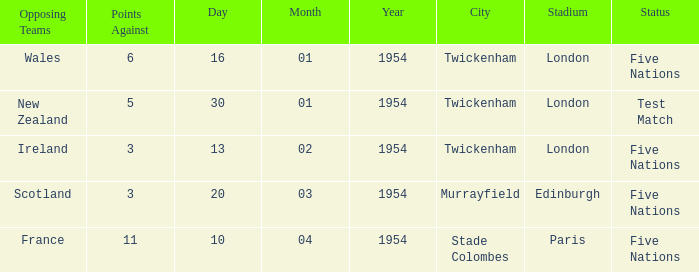What is the lowest against for games played in the stade colombes, paris venue? 11.0. 